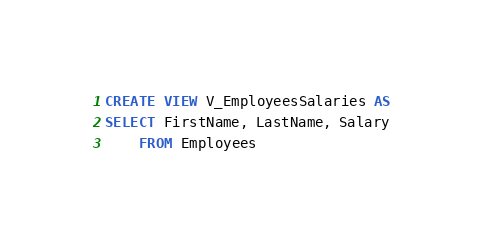<code> <loc_0><loc_0><loc_500><loc_500><_SQL_>CREATE VIEW V_EmployeesSalaries AS
SELECT FirstName, LastName, Salary
    FROM Employees</code> 